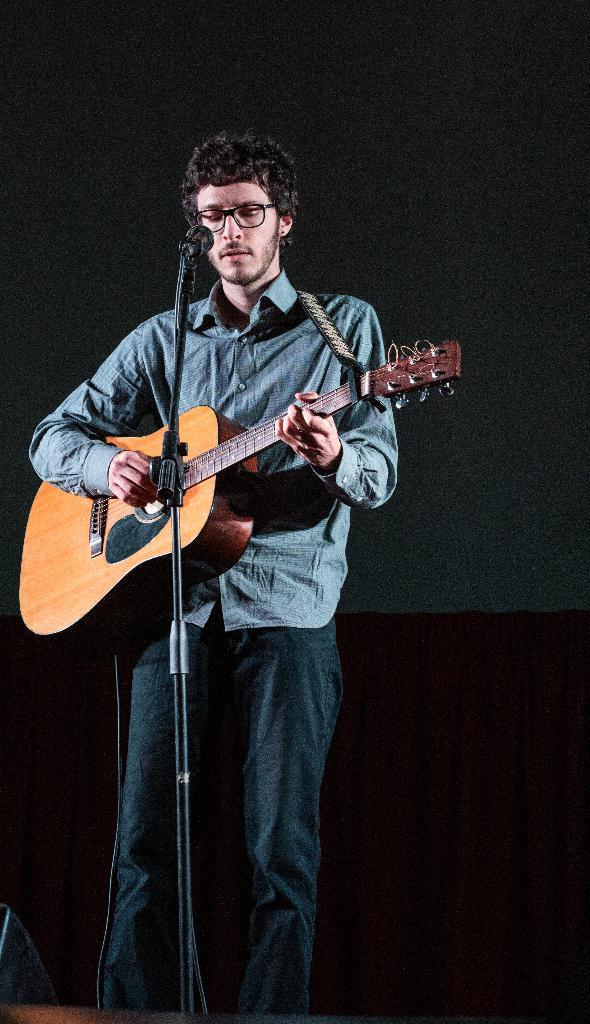Who is the main subject in the image? There is a person in the image. What is the person holding in the image? The person is holding a guitar. What is the person doing with the guitar? The person is singing a song. What is the person using to amplify their voice in the image? There is a microphone in front of the person. What type of decision can be seen in the image? There is no decision visible in the image; it features a person holding a guitar and singing into a microphone. Can you tell me how many noses are present in the image? There is no nose present in the image; it only features a person holding a guitar and singing into a microphone. 